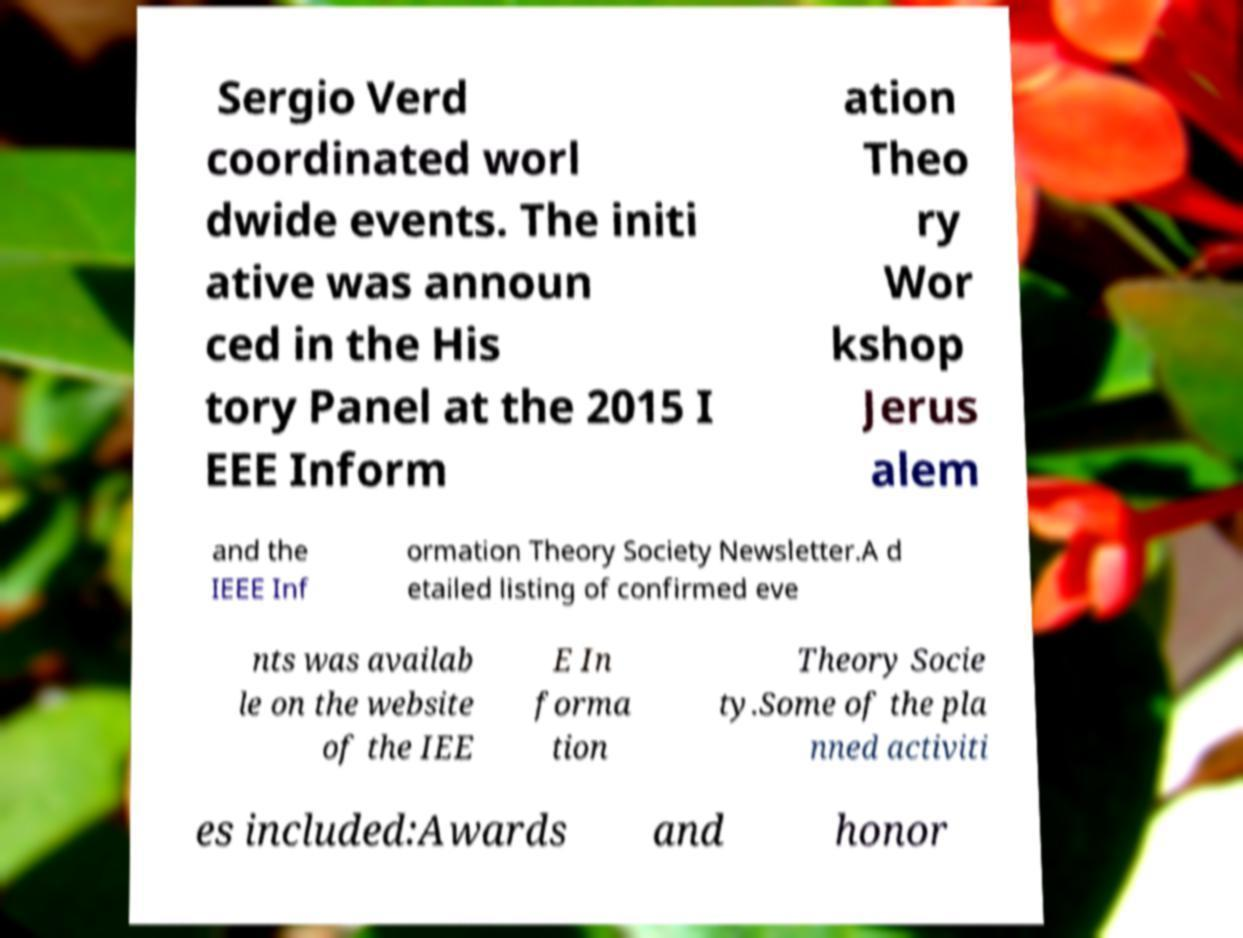For documentation purposes, I need the text within this image transcribed. Could you provide that? Sergio Verd coordinated worl dwide events. The initi ative was announ ced in the His tory Panel at the 2015 I EEE Inform ation Theo ry Wor kshop Jerus alem and the IEEE Inf ormation Theory Society Newsletter.A d etailed listing of confirmed eve nts was availab le on the website of the IEE E In forma tion Theory Socie ty.Some of the pla nned activiti es included:Awards and honor 